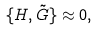<formula> <loc_0><loc_0><loc_500><loc_500>\{ H , \tilde { G } \} \approx 0 ,</formula> 